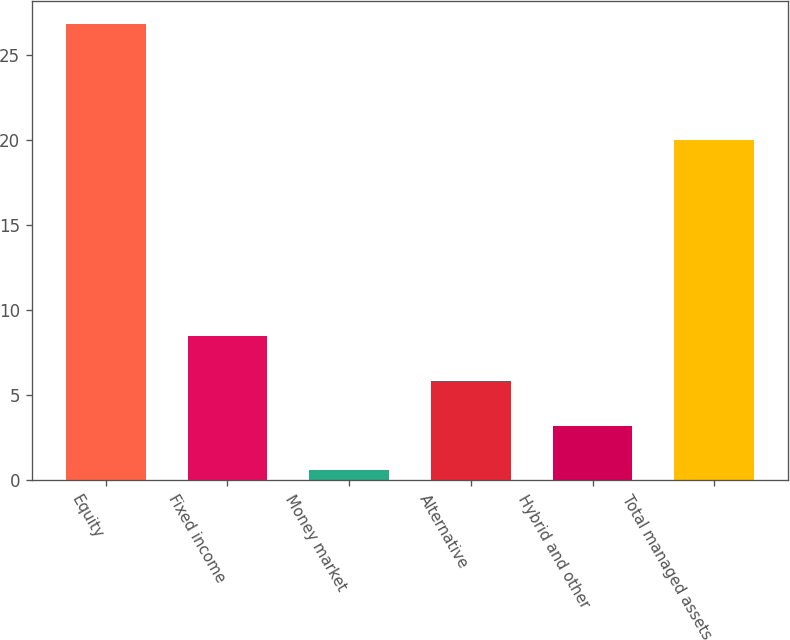Convert chart. <chart><loc_0><loc_0><loc_500><loc_500><bar_chart><fcel>Equity<fcel>Fixed income<fcel>Money market<fcel>Alternative<fcel>Hybrid and other<fcel>Total managed assets<nl><fcel>26.8<fcel>8.46<fcel>0.6<fcel>5.84<fcel>3.22<fcel>20<nl></chart> 